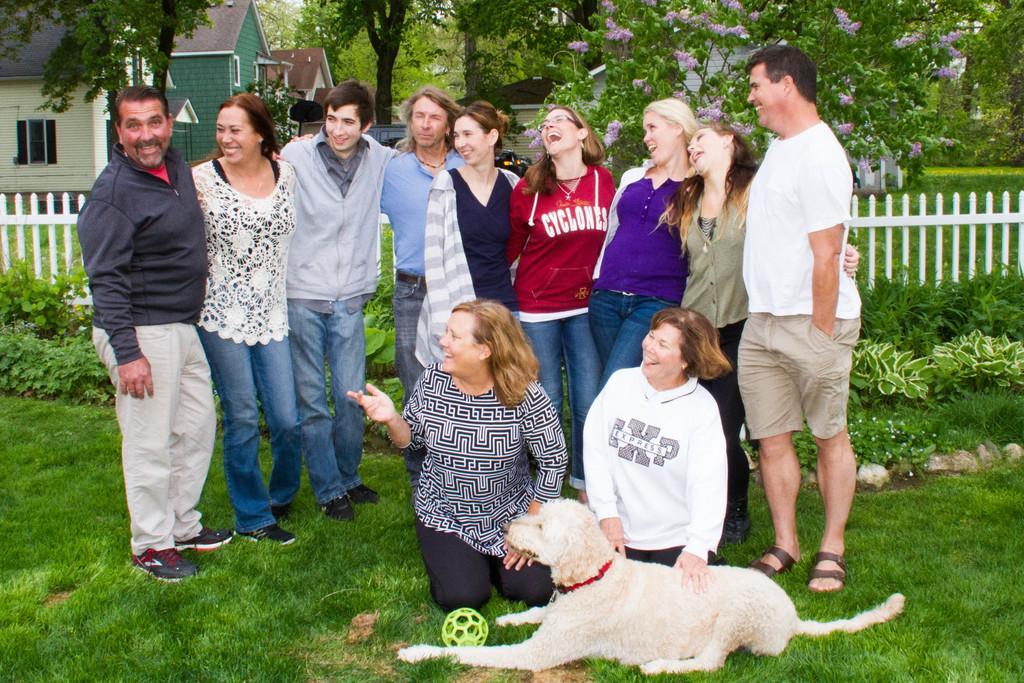Could you give a brief overview of what you see in this image? This group of people are standing on a grass. This 2 people are sitting on a grass. Beside this 2 people there is a white dog. Far there are number of trees with flowers. There are houses with roof top. This house is in green color. This house is in white color. This is fence. This are plants. 